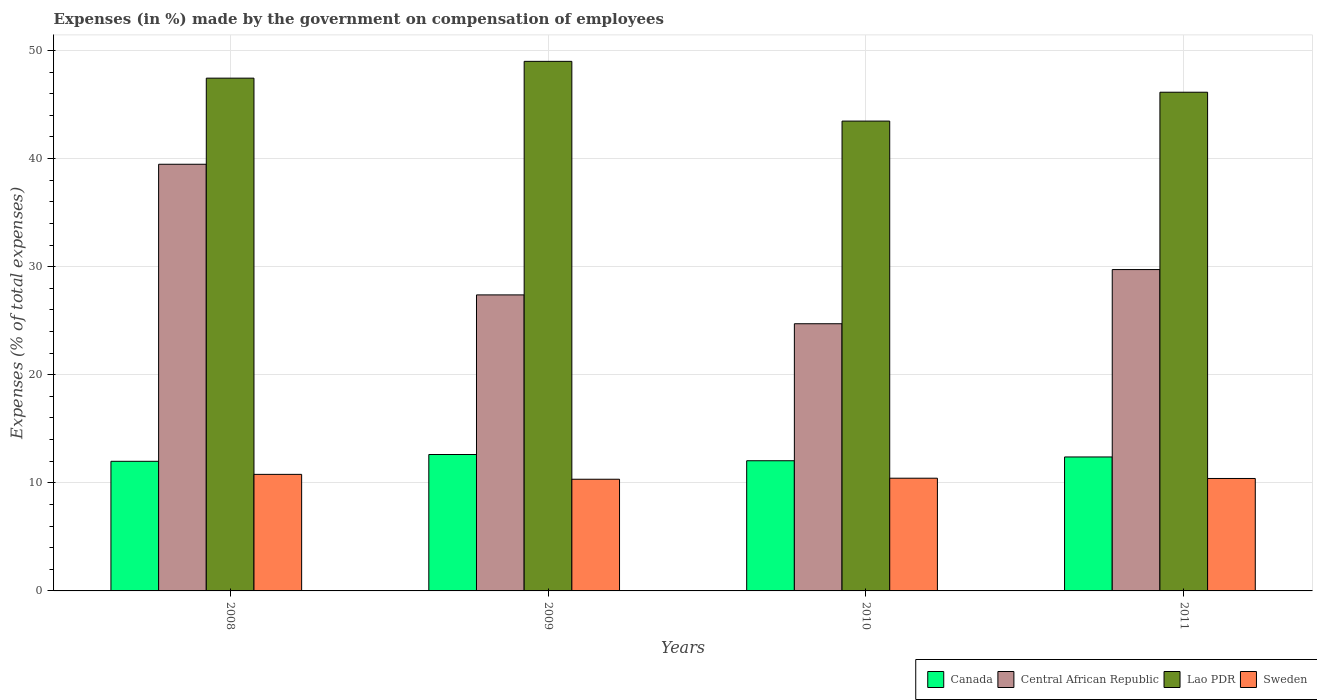Are the number of bars per tick equal to the number of legend labels?
Ensure brevity in your answer.  Yes. How many bars are there on the 1st tick from the left?
Your response must be concise. 4. How many bars are there on the 2nd tick from the right?
Keep it short and to the point. 4. What is the percentage of expenses made by the government on compensation of employees in Sweden in 2010?
Make the answer very short. 10.43. Across all years, what is the maximum percentage of expenses made by the government on compensation of employees in Lao PDR?
Provide a short and direct response. 48.99. Across all years, what is the minimum percentage of expenses made by the government on compensation of employees in Canada?
Offer a terse response. 11.99. What is the total percentage of expenses made by the government on compensation of employees in Central African Republic in the graph?
Provide a succinct answer. 121.31. What is the difference between the percentage of expenses made by the government on compensation of employees in Lao PDR in 2008 and that in 2011?
Provide a short and direct response. 1.3. What is the difference between the percentage of expenses made by the government on compensation of employees in Lao PDR in 2008 and the percentage of expenses made by the government on compensation of employees in Central African Republic in 2009?
Offer a very short reply. 20.05. What is the average percentage of expenses made by the government on compensation of employees in Sweden per year?
Offer a very short reply. 10.49. In the year 2010, what is the difference between the percentage of expenses made by the government on compensation of employees in Lao PDR and percentage of expenses made by the government on compensation of employees in Canada?
Offer a terse response. 31.42. In how many years, is the percentage of expenses made by the government on compensation of employees in Sweden greater than 18 %?
Your response must be concise. 0. What is the ratio of the percentage of expenses made by the government on compensation of employees in Central African Republic in 2008 to that in 2009?
Your answer should be very brief. 1.44. What is the difference between the highest and the second highest percentage of expenses made by the government on compensation of employees in Central African Republic?
Give a very brief answer. 9.74. What is the difference between the highest and the lowest percentage of expenses made by the government on compensation of employees in Lao PDR?
Give a very brief answer. 5.53. Is the sum of the percentage of expenses made by the government on compensation of employees in Lao PDR in 2009 and 2011 greater than the maximum percentage of expenses made by the government on compensation of employees in Central African Republic across all years?
Provide a succinct answer. Yes. What does the 3rd bar from the left in 2011 represents?
Your answer should be very brief. Lao PDR. What does the 2nd bar from the right in 2011 represents?
Provide a succinct answer. Lao PDR. How many bars are there?
Offer a terse response. 16. How many years are there in the graph?
Keep it short and to the point. 4. What is the difference between two consecutive major ticks on the Y-axis?
Ensure brevity in your answer.  10. Where does the legend appear in the graph?
Make the answer very short. Bottom right. How many legend labels are there?
Provide a short and direct response. 4. What is the title of the graph?
Offer a terse response. Expenses (in %) made by the government on compensation of employees. What is the label or title of the X-axis?
Your answer should be compact. Years. What is the label or title of the Y-axis?
Provide a succinct answer. Expenses (% of total expenses). What is the Expenses (% of total expenses) in Canada in 2008?
Provide a succinct answer. 11.99. What is the Expenses (% of total expenses) of Central African Republic in 2008?
Provide a succinct answer. 39.47. What is the Expenses (% of total expenses) in Lao PDR in 2008?
Ensure brevity in your answer.  47.44. What is the Expenses (% of total expenses) in Sweden in 2008?
Keep it short and to the point. 10.78. What is the Expenses (% of total expenses) in Canada in 2009?
Offer a very short reply. 12.62. What is the Expenses (% of total expenses) of Central African Republic in 2009?
Make the answer very short. 27.39. What is the Expenses (% of total expenses) in Lao PDR in 2009?
Offer a terse response. 48.99. What is the Expenses (% of total expenses) of Sweden in 2009?
Provide a succinct answer. 10.33. What is the Expenses (% of total expenses) of Canada in 2010?
Provide a short and direct response. 12.04. What is the Expenses (% of total expenses) in Central African Republic in 2010?
Your answer should be compact. 24.72. What is the Expenses (% of total expenses) of Lao PDR in 2010?
Give a very brief answer. 43.47. What is the Expenses (% of total expenses) of Sweden in 2010?
Offer a very short reply. 10.43. What is the Expenses (% of total expenses) in Canada in 2011?
Make the answer very short. 12.39. What is the Expenses (% of total expenses) in Central African Republic in 2011?
Offer a very short reply. 29.73. What is the Expenses (% of total expenses) of Lao PDR in 2011?
Offer a very short reply. 46.14. What is the Expenses (% of total expenses) in Sweden in 2011?
Make the answer very short. 10.4. Across all years, what is the maximum Expenses (% of total expenses) of Canada?
Keep it short and to the point. 12.62. Across all years, what is the maximum Expenses (% of total expenses) of Central African Republic?
Your answer should be compact. 39.47. Across all years, what is the maximum Expenses (% of total expenses) of Lao PDR?
Provide a short and direct response. 48.99. Across all years, what is the maximum Expenses (% of total expenses) in Sweden?
Keep it short and to the point. 10.78. Across all years, what is the minimum Expenses (% of total expenses) in Canada?
Give a very brief answer. 11.99. Across all years, what is the minimum Expenses (% of total expenses) in Central African Republic?
Keep it short and to the point. 24.72. Across all years, what is the minimum Expenses (% of total expenses) of Lao PDR?
Your answer should be compact. 43.47. Across all years, what is the minimum Expenses (% of total expenses) of Sweden?
Provide a succinct answer. 10.33. What is the total Expenses (% of total expenses) of Canada in the graph?
Make the answer very short. 49.05. What is the total Expenses (% of total expenses) of Central African Republic in the graph?
Offer a very short reply. 121.31. What is the total Expenses (% of total expenses) of Lao PDR in the graph?
Your answer should be compact. 186.04. What is the total Expenses (% of total expenses) in Sweden in the graph?
Offer a terse response. 41.95. What is the difference between the Expenses (% of total expenses) in Canada in 2008 and that in 2009?
Offer a terse response. -0.63. What is the difference between the Expenses (% of total expenses) of Central African Republic in 2008 and that in 2009?
Keep it short and to the point. 12.09. What is the difference between the Expenses (% of total expenses) of Lao PDR in 2008 and that in 2009?
Your response must be concise. -1.55. What is the difference between the Expenses (% of total expenses) of Sweden in 2008 and that in 2009?
Give a very brief answer. 0.45. What is the difference between the Expenses (% of total expenses) in Canada in 2008 and that in 2010?
Your response must be concise. -0.05. What is the difference between the Expenses (% of total expenses) in Central African Republic in 2008 and that in 2010?
Offer a very short reply. 14.76. What is the difference between the Expenses (% of total expenses) in Lao PDR in 2008 and that in 2010?
Keep it short and to the point. 3.97. What is the difference between the Expenses (% of total expenses) in Sweden in 2008 and that in 2010?
Provide a succinct answer. 0.36. What is the difference between the Expenses (% of total expenses) in Canada in 2008 and that in 2011?
Your answer should be very brief. -0.4. What is the difference between the Expenses (% of total expenses) of Central African Republic in 2008 and that in 2011?
Your answer should be compact. 9.74. What is the difference between the Expenses (% of total expenses) in Lao PDR in 2008 and that in 2011?
Your answer should be compact. 1.3. What is the difference between the Expenses (% of total expenses) of Sweden in 2008 and that in 2011?
Offer a terse response. 0.38. What is the difference between the Expenses (% of total expenses) of Canada in 2009 and that in 2010?
Provide a short and direct response. 0.58. What is the difference between the Expenses (% of total expenses) in Central African Republic in 2009 and that in 2010?
Make the answer very short. 2.67. What is the difference between the Expenses (% of total expenses) of Lao PDR in 2009 and that in 2010?
Give a very brief answer. 5.53. What is the difference between the Expenses (% of total expenses) in Sweden in 2009 and that in 2010?
Offer a very short reply. -0.1. What is the difference between the Expenses (% of total expenses) in Canada in 2009 and that in 2011?
Offer a terse response. 0.23. What is the difference between the Expenses (% of total expenses) in Central African Republic in 2009 and that in 2011?
Offer a very short reply. -2.34. What is the difference between the Expenses (% of total expenses) in Lao PDR in 2009 and that in 2011?
Provide a short and direct response. 2.86. What is the difference between the Expenses (% of total expenses) of Sweden in 2009 and that in 2011?
Offer a terse response. -0.07. What is the difference between the Expenses (% of total expenses) in Canada in 2010 and that in 2011?
Provide a succinct answer. -0.35. What is the difference between the Expenses (% of total expenses) of Central African Republic in 2010 and that in 2011?
Your answer should be compact. -5.01. What is the difference between the Expenses (% of total expenses) in Lao PDR in 2010 and that in 2011?
Your response must be concise. -2.67. What is the difference between the Expenses (% of total expenses) in Sweden in 2010 and that in 2011?
Your response must be concise. 0.02. What is the difference between the Expenses (% of total expenses) in Canada in 2008 and the Expenses (% of total expenses) in Central African Republic in 2009?
Your response must be concise. -15.4. What is the difference between the Expenses (% of total expenses) of Canada in 2008 and the Expenses (% of total expenses) of Lao PDR in 2009?
Your answer should be very brief. -37. What is the difference between the Expenses (% of total expenses) in Canada in 2008 and the Expenses (% of total expenses) in Sweden in 2009?
Offer a terse response. 1.66. What is the difference between the Expenses (% of total expenses) in Central African Republic in 2008 and the Expenses (% of total expenses) in Lao PDR in 2009?
Give a very brief answer. -9.52. What is the difference between the Expenses (% of total expenses) in Central African Republic in 2008 and the Expenses (% of total expenses) in Sweden in 2009?
Make the answer very short. 29.14. What is the difference between the Expenses (% of total expenses) in Lao PDR in 2008 and the Expenses (% of total expenses) in Sweden in 2009?
Provide a succinct answer. 37.11. What is the difference between the Expenses (% of total expenses) in Canada in 2008 and the Expenses (% of total expenses) in Central African Republic in 2010?
Your answer should be very brief. -12.73. What is the difference between the Expenses (% of total expenses) in Canada in 2008 and the Expenses (% of total expenses) in Lao PDR in 2010?
Your response must be concise. -31.48. What is the difference between the Expenses (% of total expenses) in Canada in 2008 and the Expenses (% of total expenses) in Sweden in 2010?
Ensure brevity in your answer.  1.56. What is the difference between the Expenses (% of total expenses) of Central African Republic in 2008 and the Expenses (% of total expenses) of Lao PDR in 2010?
Provide a short and direct response. -3.99. What is the difference between the Expenses (% of total expenses) in Central African Republic in 2008 and the Expenses (% of total expenses) in Sweden in 2010?
Your answer should be very brief. 29.05. What is the difference between the Expenses (% of total expenses) of Lao PDR in 2008 and the Expenses (% of total expenses) of Sweden in 2010?
Make the answer very short. 37.01. What is the difference between the Expenses (% of total expenses) in Canada in 2008 and the Expenses (% of total expenses) in Central African Republic in 2011?
Provide a short and direct response. -17.74. What is the difference between the Expenses (% of total expenses) in Canada in 2008 and the Expenses (% of total expenses) in Lao PDR in 2011?
Offer a very short reply. -34.15. What is the difference between the Expenses (% of total expenses) in Canada in 2008 and the Expenses (% of total expenses) in Sweden in 2011?
Your response must be concise. 1.59. What is the difference between the Expenses (% of total expenses) of Central African Republic in 2008 and the Expenses (% of total expenses) of Lao PDR in 2011?
Ensure brevity in your answer.  -6.66. What is the difference between the Expenses (% of total expenses) of Central African Republic in 2008 and the Expenses (% of total expenses) of Sweden in 2011?
Your answer should be very brief. 29.07. What is the difference between the Expenses (% of total expenses) in Lao PDR in 2008 and the Expenses (% of total expenses) in Sweden in 2011?
Make the answer very short. 37.04. What is the difference between the Expenses (% of total expenses) in Canada in 2009 and the Expenses (% of total expenses) in Central African Republic in 2010?
Your answer should be very brief. -12.1. What is the difference between the Expenses (% of total expenses) in Canada in 2009 and the Expenses (% of total expenses) in Lao PDR in 2010?
Ensure brevity in your answer.  -30.85. What is the difference between the Expenses (% of total expenses) in Canada in 2009 and the Expenses (% of total expenses) in Sweden in 2010?
Keep it short and to the point. 2.19. What is the difference between the Expenses (% of total expenses) of Central African Republic in 2009 and the Expenses (% of total expenses) of Lao PDR in 2010?
Your response must be concise. -16.08. What is the difference between the Expenses (% of total expenses) in Central African Republic in 2009 and the Expenses (% of total expenses) in Sweden in 2010?
Give a very brief answer. 16.96. What is the difference between the Expenses (% of total expenses) of Lao PDR in 2009 and the Expenses (% of total expenses) of Sweden in 2010?
Provide a short and direct response. 38.57. What is the difference between the Expenses (% of total expenses) in Canada in 2009 and the Expenses (% of total expenses) in Central African Republic in 2011?
Provide a succinct answer. -17.11. What is the difference between the Expenses (% of total expenses) in Canada in 2009 and the Expenses (% of total expenses) in Lao PDR in 2011?
Ensure brevity in your answer.  -33.52. What is the difference between the Expenses (% of total expenses) of Canada in 2009 and the Expenses (% of total expenses) of Sweden in 2011?
Provide a short and direct response. 2.22. What is the difference between the Expenses (% of total expenses) of Central African Republic in 2009 and the Expenses (% of total expenses) of Lao PDR in 2011?
Your answer should be very brief. -18.75. What is the difference between the Expenses (% of total expenses) of Central African Republic in 2009 and the Expenses (% of total expenses) of Sweden in 2011?
Offer a terse response. 16.98. What is the difference between the Expenses (% of total expenses) of Lao PDR in 2009 and the Expenses (% of total expenses) of Sweden in 2011?
Your response must be concise. 38.59. What is the difference between the Expenses (% of total expenses) in Canada in 2010 and the Expenses (% of total expenses) in Central African Republic in 2011?
Your answer should be compact. -17.69. What is the difference between the Expenses (% of total expenses) of Canada in 2010 and the Expenses (% of total expenses) of Lao PDR in 2011?
Make the answer very short. -34.09. What is the difference between the Expenses (% of total expenses) in Canada in 2010 and the Expenses (% of total expenses) in Sweden in 2011?
Your answer should be very brief. 1.64. What is the difference between the Expenses (% of total expenses) of Central African Republic in 2010 and the Expenses (% of total expenses) of Lao PDR in 2011?
Give a very brief answer. -21.42. What is the difference between the Expenses (% of total expenses) of Central African Republic in 2010 and the Expenses (% of total expenses) of Sweden in 2011?
Your response must be concise. 14.31. What is the difference between the Expenses (% of total expenses) in Lao PDR in 2010 and the Expenses (% of total expenses) in Sweden in 2011?
Ensure brevity in your answer.  33.06. What is the average Expenses (% of total expenses) in Canada per year?
Provide a short and direct response. 12.26. What is the average Expenses (% of total expenses) of Central African Republic per year?
Give a very brief answer. 30.33. What is the average Expenses (% of total expenses) in Lao PDR per year?
Your answer should be very brief. 46.51. What is the average Expenses (% of total expenses) in Sweden per year?
Keep it short and to the point. 10.49. In the year 2008, what is the difference between the Expenses (% of total expenses) of Canada and Expenses (% of total expenses) of Central African Republic?
Provide a succinct answer. -27.48. In the year 2008, what is the difference between the Expenses (% of total expenses) of Canada and Expenses (% of total expenses) of Lao PDR?
Your answer should be compact. -35.45. In the year 2008, what is the difference between the Expenses (% of total expenses) of Canada and Expenses (% of total expenses) of Sweden?
Your response must be concise. 1.21. In the year 2008, what is the difference between the Expenses (% of total expenses) of Central African Republic and Expenses (% of total expenses) of Lao PDR?
Offer a very short reply. -7.97. In the year 2008, what is the difference between the Expenses (% of total expenses) in Central African Republic and Expenses (% of total expenses) in Sweden?
Offer a very short reply. 28.69. In the year 2008, what is the difference between the Expenses (% of total expenses) in Lao PDR and Expenses (% of total expenses) in Sweden?
Keep it short and to the point. 36.66. In the year 2009, what is the difference between the Expenses (% of total expenses) in Canada and Expenses (% of total expenses) in Central African Republic?
Offer a terse response. -14.77. In the year 2009, what is the difference between the Expenses (% of total expenses) in Canada and Expenses (% of total expenses) in Lao PDR?
Your answer should be very brief. -36.37. In the year 2009, what is the difference between the Expenses (% of total expenses) in Canada and Expenses (% of total expenses) in Sweden?
Offer a very short reply. 2.29. In the year 2009, what is the difference between the Expenses (% of total expenses) of Central African Republic and Expenses (% of total expenses) of Lao PDR?
Your answer should be compact. -21.61. In the year 2009, what is the difference between the Expenses (% of total expenses) of Central African Republic and Expenses (% of total expenses) of Sweden?
Offer a terse response. 17.05. In the year 2009, what is the difference between the Expenses (% of total expenses) in Lao PDR and Expenses (% of total expenses) in Sweden?
Keep it short and to the point. 38.66. In the year 2010, what is the difference between the Expenses (% of total expenses) in Canada and Expenses (% of total expenses) in Central African Republic?
Your answer should be very brief. -12.67. In the year 2010, what is the difference between the Expenses (% of total expenses) of Canada and Expenses (% of total expenses) of Lao PDR?
Offer a very short reply. -31.42. In the year 2010, what is the difference between the Expenses (% of total expenses) in Canada and Expenses (% of total expenses) in Sweden?
Your answer should be compact. 1.62. In the year 2010, what is the difference between the Expenses (% of total expenses) in Central African Republic and Expenses (% of total expenses) in Lao PDR?
Your answer should be compact. -18.75. In the year 2010, what is the difference between the Expenses (% of total expenses) in Central African Republic and Expenses (% of total expenses) in Sweden?
Provide a short and direct response. 14.29. In the year 2010, what is the difference between the Expenses (% of total expenses) of Lao PDR and Expenses (% of total expenses) of Sweden?
Offer a very short reply. 33.04. In the year 2011, what is the difference between the Expenses (% of total expenses) of Canada and Expenses (% of total expenses) of Central African Republic?
Ensure brevity in your answer.  -17.34. In the year 2011, what is the difference between the Expenses (% of total expenses) in Canada and Expenses (% of total expenses) in Lao PDR?
Keep it short and to the point. -33.74. In the year 2011, what is the difference between the Expenses (% of total expenses) of Canada and Expenses (% of total expenses) of Sweden?
Give a very brief answer. 1.99. In the year 2011, what is the difference between the Expenses (% of total expenses) of Central African Republic and Expenses (% of total expenses) of Lao PDR?
Offer a terse response. -16.41. In the year 2011, what is the difference between the Expenses (% of total expenses) in Central African Republic and Expenses (% of total expenses) in Sweden?
Your response must be concise. 19.33. In the year 2011, what is the difference between the Expenses (% of total expenses) in Lao PDR and Expenses (% of total expenses) in Sweden?
Give a very brief answer. 35.74. What is the ratio of the Expenses (% of total expenses) in Canada in 2008 to that in 2009?
Provide a short and direct response. 0.95. What is the ratio of the Expenses (% of total expenses) in Central African Republic in 2008 to that in 2009?
Give a very brief answer. 1.44. What is the ratio of the Expenses (% of total expenses) in Lao PDR in 2008 to that in 2009?
Your response must be concise. 0.97. What is the ratio of the Expenses (% of total expenses) in Sweden in 2008 to that in 2009?
Your answer should be very brief. 1.04. What is the ratio of the Expenses (% of total expenses) in Central African Republic in 2008 to that in 2010?
Offer a terse response. 1.6. What is the ratio of the Expenses (% of total expenses) in Lao PDR in 2008 to that in 2010?
Keep it short and to the point. 1.09. What is the ratio of the Expenses (% of total expenses) in Sweden in 2008 to that in 2010?
Ensure brevity in your answer.  1.03. What is the ratio of the Expenses (% of total expenses) in Canada in 2008 to that in 2011?
Offer a very short reply. 0.97. What is the ratio of the Expenses (% of total expenses) of Central African Republic in 2008 to that in 2011?
Give a very brief answer. 1.33. What is the ratio of the Expenses (% of total expenses) in Lao PDR in 2008 to that in 2011?
Offer a very short reply. 1.03. What is the ratio of the Expenses (% of total expenses) of Sweden in 2008 to that in 2011?
Ensure brevity in your answer.  1.04. What is the ratio of the Expenses (% of total expenses) of Canada in 2009 to that in 2010?
Your answer should be very brief. 1.05. What is the ratio of the Expenses (% of total expenses) of Central African Republic in 2009 to that in 2010?
Keep it short and to the point. 1.11. What is the ratio of the Expenses (% of total expenses) in Lao PDR in 2009 to that in 2010?
Your answer should be compact. 1.13. What is the ratio of the Expenses (% of total expenses) in Sweden in 2009 to that in 2010?
Provide a short and direct response. 0.99. What is the ratio of the Expenses (% of total expenses) of Canada in 2009 to that in 2011?
Offer a terse response. 1.02. What is the ratio of the Expenses (% of total expenses) in Central African Republic in 2009 to that in 2011?
Your response must be concise. 0.92. What is the ratio of the Expenses (% of total expenses) in Lao PDR in 2009 to that in 2011?
Your answer should be compact. 1.06. What is the ratio of the Expenses (% of total expenses) of Canada in 2010 to that in 2011?
Make the answer very short. 0.97. What is the ratio of the Expenses (% of total expenses) in Central African Republic in 2010 to that in 2011?
Your response must be concise. 0.83. What is the ratio of the Expenses (% of total expenses) in Lao PDR in 2010 to that in 2011?
Make the answer very short. 0.94. What is the difference between the highest and the second highest Expenses (% of total expenses) of Canada?
Provide a succinct answer. 0.23. What is the difference between the highest and the second highest Expenses (% of total expenses) in Central African Republic?
Give a very brief answer. 9.74. What is the difference between the highest and the second highest Expenses (% of total expenses) of Lao PDR?
Your response must be concise. 1.55. What is the difference between the highest and the second highest Expenses (% of total expenses) in Sweden?
Make the answer very short. 0.36. What is the difference between the highest and the lowest Expenses (% of total expenses) in Canada?
Give a very brief answer. 0.63. What is the difference between the highest and the lowest Expenses (% of total expenses) of Central African Republic?
Make the answer very short. 14.76. What is the difference between the highest and the lowest Expenses (% of total expenses) of Lao PDR?
Offer a terse response. 5.53. What is the difference between the highest and the lowest Expenses (% of total expenses) in Sweden?
Your answer should be compact. 0.45. 